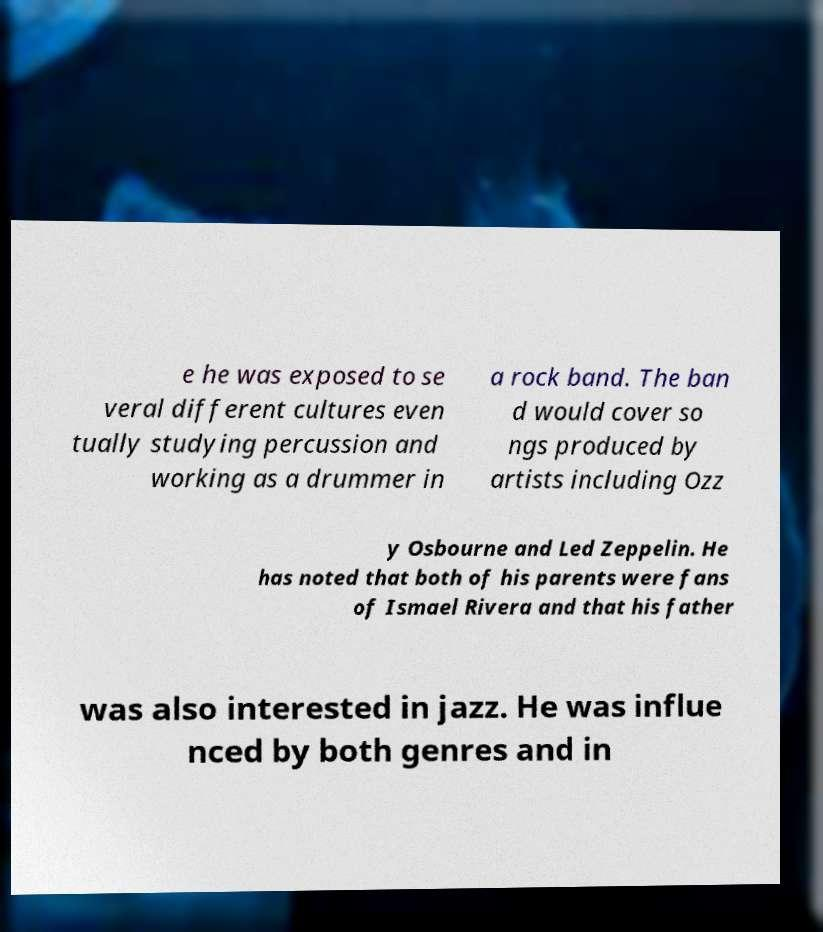I need the written content from this picture converted into text. Can you do that? e he was exposed to se veral different cultures even tually studying percussion and working as a drummer in a rock band. The ban d would cover so ngs produced by artists including Ozz y Osbourne and Led Zeppelin. He has noted that both of his parents were fans of Ismael Rivera and that his father was also interested in jazz. He was influe nced by both genres and in 